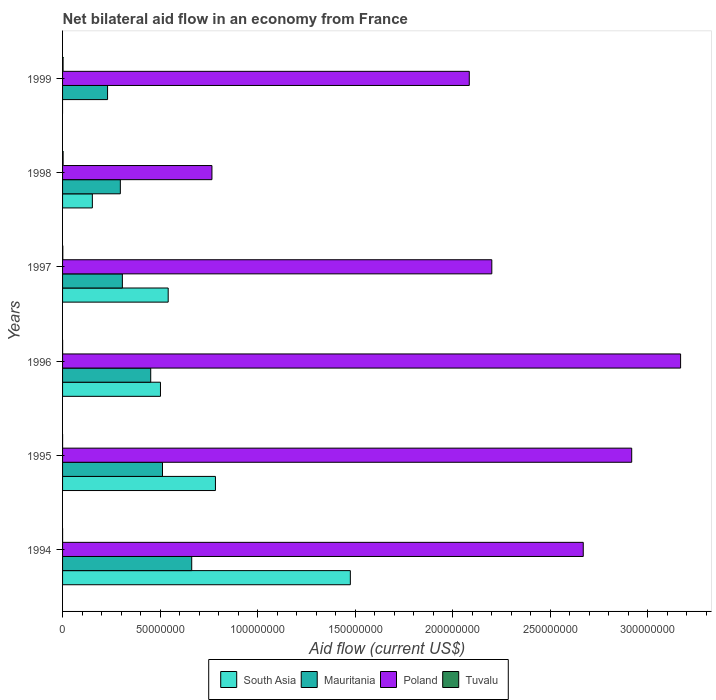How many different coloured bars are there?
Give a very brief answer. 4. How many groups of bars are there?
Ensure brevity in your answer.  6. Are the number of bars per tick equal to the number of legend labels?
Make the answer very short. No. How many bars are there on the 3rd tick from the top?
Your answer should be compact. 4. What is the label of the 2nd group of bars from the top?
Your answer should be compact. 1998. What is the net bilateral aid flow in South Asia in 1998?
Your answer should be compact. 1.53e+07. Across all years, what is the maximum net bilateral aid flow in South Asia?
Your response must be concise. 1.48e+08. What is the total net bilateral aid flow in South Asia in the graph?
Offer a very short reply. 3.46e+08. What is the difference between the net bilateral aid flow in Poland in 1994 and that in 1998?
Ensure brevity in your answer.  1.90e+08. What is the difference between the net bilateral aid flow in Poland in 1994 and the net bilateral aid flow in Tuvalu in 1996?
Your response must be concise. 2.67e+08. What is the average net bilateral aid flow in South Asia per year?
Keep it short and to the point. 5.76e+07. In the year 1995, what is the difference between the net bilateral aid flow in South Asia and net bilateral aid flow in Tuvalu?
Provide a short and direct response. 7.84e+07. In how many years, is the net bilateral aid flow in Mauritania greater than 10000000 US$?
Give a very brief answer. 6. What is the ratio of the net bilateral aid flow in Poland in 1998 to that in 1999?
Provide a short and direct response. 0.37. Is the net bilateral aid flow in Tuvalu in 1994 less than that in 1995?
Offer a very short reply. No. What is the difference between the highest and the second highest net bilateral aid flow in Tuvalu?
Your answer should be very brief. 2.00e+04. Is it the case that in every year, the sum of the net bilateral aid flow in South Asia and net bilateral aid flow in Poland is greater than the sum of net bilateral aid flow in Tuvalu and net bilateral aid flow in Mauritania?
Offer a terse response. Yes. Is it the case that in every year, the sum of the net bilateral aid flow in Poland and net bilateral aid flow in Mauritania is greater than the net bilateral aid flow in Tuvalu?
Offer a terse response. Yes. Are all the bars in the graph horizontal?
Keep it short and to the point. Yes. How many years are there in the graph?
Offer a terse response. 6. What is the difference between two consecutive major ticks on the X-axis?
Your answer should be very brief. 5.00e+07. Are the values on the major ticks of X-axis written in scientific E-notation?
Offer a very short reply. No. Where does the legend appear in the graph?
Your response must be concise. Bottom center. How are the legend labels stacked?
Your answer should be compact. Horizontal. What is the title of the graph?
Your answer should be compact. Net bilateral aid flow in an economy from France. What is the Aid flow (current US$) of South Asia in 1994?
Your answer should be very brief. 1.48e+08. What is the Aid flow (current US$) in Mauritania in 1994?
Provide a short and direct response. 6.62e+07. What is the Aid flow (current US$) of Poland in 1994?
Keep it short and to the point. 2.67e+08. What is the Aid flow (current US$) in Tuvalu in 1994?
Offer a very short reply. 10000. What is the Aid flow (current US$) in South Asia in 1995?
Provide a short and direct response. 7.84e+07. What is the Aid flow (current US$) in Mauritania in 1995?
Offer a terse response. 5.12e+07. What is the Aid flow (current US$) of Poland in 1995?
Your answer should be very brief. 2.92e+08. What is the Aid flow (current US$) in South Asia in 1996?
Offer a terse response. 5.02e+07. What is the Aid flow (current US$) of Mauritania in 1996?
Give a very brief answer. 4.52e+07. What is the Aid flow (current US$) in Poland in 1996?
Your answer should be compact. 3.17e+08. What is the Aid flow (current US$) in Tuvalu in 1996?
Give a very brief answer. 2.00e+04. What is the Aid flow (current US$) of South Asia in 1997?
Keep it short and to the point. 5.42e+07. What is the Aid flow (current US$) in Mauritania in 1997?
Ensure brevity in your answer.  3.07e+07. What is the Aid flow (current US$) of Poland in 1997?
Give a very brief answer. 2.20e+08. What is the Aid flow (current US$) of Tuvalu in 1997?
Provide a succinct answer. 1.30e+05. What is the Aid flow (current US$) of South Asia in 1998?
Your answer should be very brief. 1.53e+07. What is the Aid flow (current US$) of Mauritania in 1998?
Provide a short and direct response. 2.96e+07. What is the Aid flow (current US$) in Poland in 1998?
Make the answer very short. 7.66e+07. What is the Aid flow (current US$) of Mauritania in 1999?
Provide a short and direct response. 2.31e+07. What is the Aid flow (current US$) of Poland in 1999?
Your response must be concise. 2.09e+08. Across all years, what is the maximum Aid flow (current US$) of South Asia?
Your answer should be compact. 1.48e+08. Across all years, what is the maximum Aid flow (current US$) of Mauritania?
Give a very brief answer. 6.62e+07. Across all years, what is the maximum Aid flow (current US$) of Poland?
Give a very brief answer. 3.17e+08. Across all years, what is the minimum Aid flow (current US$) in Mauritania?
Make the answer very short. 2.31e+07. Across all years, what is the minimum Aid flow (current US$) of Poland?
Your response must be concise. 7.66e+07. What is the total Aid flow (current US$) of South Asia in the graph?
Offer a very short reply. 3.46e+08. What is the total Aid flow (current US$) of Mauritania in the graph?
Offer a very short reply. 2.46e+08. What is the total Aid flow (current US$) of Poland in the graph?
Give a very brief answer. 1.38e+09. What is the total Aid flow (current US$) in Tuvalu in the graph?
Give a very brief answer. 7.10e+05. What is the difference between the Aid flow (current US$) in South Asia in 1994 and that in 1995?
Offer a very short reply. 6.92e+07. What is the difference between the Aid flow (current US$) of Mauritania in 1994 and that in 1995?
Offer a very short reply. 1.50e+07. What is the difference between the Aid flow (current US$) of Poland in 1994 and that in 1995?
Keep it short and to the point. -2.48e+07. What is the difference between the Aid flow (current US$) of South Asia in 1994 and that in 1996?
Ensure brevity in your answer.  9.74e+07. What is the difference between the Aid flow (current US$) of Mauritania in 1994 and that in 1996?
Give a very brief answer. 2.10e+07. What is the difference between the Aid flow (current US$) in Poland in 1994 and that in 1996?
Provide a short and direct response. -4.99e+07. What is the difference between the Aid flow (current US$) of South Asia in 1994 and that in 1997?
Your answer should be very brief. 9.34e+07. What is the difference between the Aid flow (current US$) in Mauritania in 1994 and that in 1997?
Your response must be concise. 3.56e+07. What is the difference between the Aid flow (current US$) of Poland in 1994 and that in 1997?
Your answer should be very brief. 4.69e+07. What is the difference between the Aid flow (current US$) of Tuvalu in 1994 and that in 1997?
Your answer should be compact. -1.20e+05. What is the difference between the Aid flow (current US$) of South Asia in 1994 and that in 1998?
Keep it short and to the point. 1.32e+08. What is the difference between the Aid flow (current US$) in Mauritania in 1994 and that in 1998?
Make the answer very short. 3.66e+07. What is the difference between the Aid flow (current US$) in Poland in 1994 and that in 1998?
Your response must be concise. 1.90e+08. What is the difference between the Aid flow (current US$) in Mauritania in 1994 and that in 1999?
Offer a very short reply. 4.32e+07. What is the difference between the Aid flow (current US$) in Poland in 1994 and that in 1999?
Keep it short and to the point. 5.84e+07. What is the difference between the Aid flow (current US$) of South Asia in 1995 and that in 1996?
Make the answer very short. 2.82e+07. What is the difference between the Aid flow (current US$) of Mauritania in 1995 and that in 1996?
Your response must be concise. 6.04e+06. What is the difference between the Aid flow (current US$) in Poland in 1995 and that in 1996?
Your response must be concise. -2.51e+07. What is the difference between the Aid flow (current US$) of South Asia in 1995 and that in 1997?
Offer a terse response. 2.42e+07. What is the difference between the Aid flow (current US$) in Mauritania in 1995 and that in 1997?
Provide a succinct answer. 2.06e+07. What is the difference between the Aid flow (current US$) in Poland in 1995 and that in 1997?
Keep it short and to the point. 7.18e+07. What is the difference between the Aid flow (current US$) of South Asia in 1995 and that in 1998?
Your response must be concise. 6.31e+07. What is the difference between the Aid flow (current US$) of Mauritania in 1995 and that in 1998?
Provide a short and direct response. 2.16e+07. What is the difference between the Aid flow (current US$) of Poland in 1995 and that in 1998?
Ensure brevity in your answer.  2.15e+08. What is the difference between the Aid flow (current US$) in Mauritania in 1995 and that in 1999?
Your answer should be compact. 2.82e+07. What is the difference between the Aid flow (current US$) of Poland in 1995 and that in 1999?
Give a very brief answer. 8.33e+07. What is the difference between the Aid flow (current US$) in Tuvalu in 1995 and that in 1999?
Provide a short and direct response. -2.50e+05. What is the difference between the Aid flow (current US$) in South Asia in 1996 and that in 1997?
Offer a terse response. -3.96e+06. What is the difference between the Aid flow (current US$) of Mauritania in 1996 and that in 1997?
Provide a succinct answer. 1.45e+07. What is the difference between the Aid flow (current US$) in Poland in 1996 and that in 1997?
Make the answer very short. 9.68e+07. What is the difference between the Aid flow (current US$) in South Asia in 1996 and that in 1998?
Give a very brief answer. 3.49e+07. What is the difference between the Aid flow (current US$) in Mauritania in 1996 and that in 1998?
Give a very brief answer. 1.56e+07. What is the difference between the Aid flow (current US$) of Poland in 1996 and that in 1998?
Keep it short and to the point. 2.40e+08. What is the difference between the Aid flow (current US$) in Tuvalu in 1996 and that in 1998?
Keep it short and to the point. -2.60e+05. What is the difference between the Aid flow (current US$) in Mauritania in 1996 and that in 1999?
Ensure brevity in your answer.  2.21e+07. What is the difference between the Aid flow (current US$) of Poland in 1996 and that in 1999?
Your answer should be very brief. 1.08e+08. What is the difference between the Aid flow (current US$) of Tuvalu in 1996 and that in 1999?
Offer a terse response. -2.40e+05. What is the difference between the Aid flow (current US$) of South Asia in 1997 and that in 1998?
Offer a terse response. 3.89e+07. What is the difference between the Aid flow (current US$) in Mauritania in 1997 and that in 1998?
Make the answer very short. 1.04e+06. What is the difference between the Aid flow (current US$) in Poland in 1997 and that in 1998?
Your answer should be compact. 1.44e+08. What is the difference between the Aid flow (current US$) in Mauritania in 1997 and that in 1999?
Give a very brief answer. 7.59e+06. What is the difference between the Aid flow (current US$) of Poland in 1997 and that in 1999?
Give a very brief answer. 1.16e+07. What is the difference between the Aid flow (current US$) of Tuvalu in 1997 and that in 1999?
Your answer should be very brief. -1.30e+05. What is the difference between the Aid flow (current US$) in Mauritania in 1998 and that in 1999?
Offer a very short reply. 6.55e+06. What is the difference between the Aid flow (current US$) of Poland in 1998 and that in 1999?
Offer a very short reply. -1.32e+08. What is the difference between the Aid flow (current US$) in Tuvalu in 1998 and that in 1999?
Provide a succinct answer. 2.00e+04. What is the difference between the Aid flow (current US$) of South Asia in 1994 and the Aid flow (current US$) of Mauritania in 1995?
Ensure brevity in your answer.  9.63e+07. What is the difference between the Aid flow (current US$) in South Asia in 1994 and the Aid flow (current US$) in Poland in 1995?
Offer a very short reply. -1.44e+08. What is the difference between the Aid flow (current US$) in South Asia in 1994 and the Aid flow (current US$) in Tuvalu in 1995?
Offer a very short reply. 1.48e+08. What is the difference between the Aid flow (current US$) of Mauritania in 1994 and the Aid flow (current US$) of Poland in 1995?
Keep it short and to the point. -2.26e+08. What is the difference between the Aid flow (current US$) of Mauritania in 1994 and the Aid flow (current US$) of Tuvalu in 1995?
Provide a short and direct response. 6.62e+07. What is the difference between the Aid flow (current US$) in Poland in 1994 and the Aid flow (current US$) in Tuvalu in 1995?
Provide a short and direct response. 2.67e+08. What is the difference between the Aid flow (current US$) in South Asia in 1994 and the Aid flow (current US$) in Mauritania in 1996?
Offer a very short reply. 1.02e+08. What is the difference between the Aid flow (current US$) of South Asia in 1994 and the Aid flow (current US$) of Poland in 1996?
Provide a succinct answer. -1.69e+08. What is the difference between the Aid flow (current US$) in South Asia in 1994 and the Aid flow (current US$) in Tuvalu in 1996?
Give a very brief answer. 1.48e+08. What is the difference between the Aid flow (current US$) of Mauritania in 1994 and the Aid flow (current US$) of Poland in 1996?
Provide a succinct answer. -2.51e+08. What is the difference between the Aid flow (current US$) of Mauritania in 1994 and the Aid flow (current US$) of Tuvalu in 1996?
Offer a terse response. 6.62e+07. What is the difference between the Aid flow (current US$) in Poland in 1994 and the Aid flow (current US$) in Tuvalu in 1996?
Give a very brief answer. 2.67e+08. What is the difference between the Aid flow (current US$) of South Asia in 1994 and the Aid flow (current US$) of Mauritania in 1997?
Your answer should be very brief. 1.17e+08. What is the difference between the Aid flow (current US$) in South Asia in 1994 and the Aid flow (current US$) in Poland in 1997?
Your response must be concise. -7.26e+07. What is the difference between the Aid flow (current US$) in South Asia in 1994 and the Aid flow (current US$) in Tuvalu in 1997?
Offer a terse response. 1.47e+08. What is the difference between the Aid flow (current US$) of Mauritania in 1994 and the Aid flow (current US$) of Poland in 1997?
Offer a very short reply. -1.54e+08. What is the difference between the Aid flow (current US$) in Mauritania in 1994 and the Aid flow (current US$) in Tuvalu in 1997?
Offer a terse response. 6.61e+07. What is the difference between the Aid flow (current US$) of Poland in 1994 and the Aid flow (current US$) of Tuvalu in 1997?
Ensure brevity in your answer.  2.67e+08. What is the difference between the Aid flow (current US$) of South Asia in 1994 and the Aid flow (current US$) of Mauritania in 1998?
Keep it short and to the point. 1.18e+08. What is the difference between the Aid flow (current US$) in South Asia in 1994 and the Aid flow (current US$) in Poland in 1998?
Keep it short and to the point. 7.10e+07. What is the difference between the Aid flow (current US$) in South Asia in 1994 and the Aid flow (current US$) in Tuvalu in 1998?
Offer a terse response. 1.47e+08. What is the difference between the Aid flow (current US$) of Mauritania in 1994 and the Aid flow (current US$) of Poland in 1998?
Provide a succinct answer. -1.04e+07. What is the difference between the Aid flow (current US$) of Mauritania in 1994 and the Aid flow (current US$) of Tuvalu in 1998?
Provide a succinct answer. 6.60e+07. What is the difference between the Aid flow (current US$) of Poland in 1994 and the Aid flow (current US$) of Tuvalu in 1998?
Give a very brief answer. 2.67e+08. What is the difference between the Aid flow (current US$) of South Asia in 1994 and the Aid flow (current US$) of Mauritania in 1999?
Keep it short and to the point. 1.25e+08. What is the difference between the Aid flow (current US$) of South Asia in 1994 and the Aid flow (current US$) of Poland in 1999?
Provide a succinct answer. -6.10e+07. What is the difference between the Aid flow (current US$) of South Asia in 1994 and the Aid flow (current US$) of Tuvalu in 1999?
Your answer should be very brief. 1.47e+08. What is the difference between the Aid flow (current US$) in Mauritania in 1994 and the Aid flow (current US$) in Poland in 1999?
Your answer should be compact. -1.42e+08. What is the difference between the Aid flow (current US$) in Mauritania in 1994 and the Aid flow (current US$) in Tuvalu in 1999?
Ensure brevity in your answer.  6.60e+07. What is the difference between the Aid flow (current US$) of Poland in 1994 and the Aid flow (current US$) of Tuvalu in 1999?
Offer a very short reply. 2.67e+08. What is the difference between the Aid flow (current US$) in South Asia in 1995 and the Aid flow (current US$) in Mauritania in 1996?
Your response must be concise. 3.32e+07. What is the difference between the Aid flow (current US$) in South Asia in 1995 and the Aid flow (current US$) in Poland in 1996?
Your response must be concise. -2.39e+08. What is the difference between the Aid flow (current US$) in South Asia in 1995 and the Aid flow (current US$) in Tuvalu in 1996?
Make the answer very short. 7.84e+07. What is the difference between the Aid flow (current US$) of Mauritania in 1995 and the Aid flow (current US$) of Poland in 1996?
Make the answer very short. -2.66e+08. What is the difference between the Aid flow (current US$) in Mauritania in 1995 and the Aid flow (current US$) in Tuvalu in 1996?
Provide a short and direct response. 5.12e+07. What is the difference between the Aid flow (current US$) of Poland in 1995 and the Aid flow (current US$) of Tuvalu in 1996?
Your answer should be compact. 2.92e+08. What is the difference between the Aid flow (current US$) in South Asia in 1995 and the Aid flow (current US$) in Mauritania in 1997?
Provide a succinct answer. 4.77e+07. What is the difference between the Aid flow (current US$) in South Asia in 1995 and the Aid flow (current US$) in Poland in 1997?
Keep it short and to the point. -1.42e+08. What is the difference between the Aid flow (current US$) in South Asia in 1995 and the Aid flow (current US$) in Tuvalu in 1997?
Ensure brevity in your answer.  7.83e+07. What is the difference between the Aid flow (current US$) in Mauritania in 1995 and the Aid flow (current US$) in Poland in 1997?
Offer a terse response. -1.69e+08. What is the difference between the Aid flow (current US$) of Mauritania in 1995 and the Aid flow (current US$) of Tuvalu in 1997?
Ensure brevity in your answer.  5.11e+07. What is the difference between the Aid flow (current US$) of Poland in 1995 and the Aid flow (current US$) of Tuvalu in 1997?
Give a very brief answer. 2.92e+08. What is the difference between the Aid flow (current US$) of South Asia in 1995 and the Aid flow (current US$) of Mauritania in 1998?
Provide a succinct answer. 4.88e+07. What is the difference between the Aid flow (current US$) in South Asia in 1995 and the Aid flow (current US$) in Poland in 1998?
Provide a succinct answer. 1.79e+06. What is the difference between the Aid flow (current US$) of South Asia in 1995 and the Aid flow (current US$) of Tuvalu in 1998?
Your answer should be very brief. 7.81e+07. What is the difference between the Aid flow (current US$) in Mauritania in 1995 and the Aid flow (current US$) in Poland in 1998?
Keep it short and to the point. -2.54e+07. What is the difference between the Aid flow (current US$) of Mauritania in 1995 and the Aid flow (current US$) of Tuvalu in 1998?
Your answer should be compact. 5.10e+07. What is the difference between the Aid flow (current US$) of Poland in 1995 and the Aid flow (current US$) of Tuvalu in 1998?
Provide a succinct answer. 2.92e+08. What is the difference between the Aid flow (current US$) in South Asia in 1995 and the Aid flow (current US$) in Mauritania in 1999?
Offer a terse response. 5.53e+07. What is the difference between the Aid flow (current US$) in South Asia in 1995 and the Aid flow (current US$) in Poland in 1999?
Make the answer very short. -1.30e+08. What is the difference between the Aid flow (current US$) in South Asia in 1995 and the Aid flow (current US$) in Tuvalu in 1999?
Provide a short and direct response. 7.81e+07. What is the difference between the Aid flow (current US$) of Mauritania in 1995 and the Aid flow (current US$) of Poland in 1999?
Make the answer very short. -1.57e+08. What is the difference between the Aid flow (current US$) in Mauritania in 1995 and the Aid flow (current US$) in Tuvalu in 1999?
Make the answer very short. 5.10e+07. What is the difference between the Aid flow (current US$) in Poland in 1995 and the Aid flow (current US$) in Tuvalu in 1999?
Offer a very short reply. 2.92e+08. What is the difference between the Aid flow (current US$) in South Asia in 1996 and the Aid flow (current US$) in Mauritania in 1997?
Your response must be concise. 1.95e+07. What is the difference between the Aid flow (current US$) of South Asia in 1996 and the Aid flow (current US$) of Poland in 1997?
Your answer should be very brief. -1.70e+08. What is the difference between the Aid flow (current US$) in South Asia in 1996 and the Aid flow (current US$) in Tuvalu in 1997?
Keep it short and to the point. 5.01e+07. What is the difference between the Aid flow (current US$) in Mauritania in 1996 and the Aid flow (current US$) in Poland in 1997?
Make the answer very short. -1.75e+08. What is the difference between the Aid flow (current US$) of Mauritania in 1996 and the Aid flow (current US$) of Tuvalu in 1997?
Your answer should be very brief. 4.51e+07. What is the difference between the Aid flow (current US$) of Poland in 1996 and the Aid flow (current US$) of Tuvalu in 1997?
Provide a short and direct response. 3.17e+08. What is the difference between the Aid flow (current US$) in South Asia in 1996 and the Aid flow (current US$) in Mauritania in 1998?
Your answer should be compact. 2.06e+07. What is the difference between the Aid flow (current US$) in South Asia in 1996 and the Aid flow (current US$) in Poland in 1998?
Your answer should be very brief. -2.64e+07. What is the difference between the Aid flow (current US$) of South Asia in 1996 and the Aid flow (current US$) of Tuvalu in 1998?
Give a very brief answer. 4.99e+07. What is the difference between the Aid flow (current US$) of Mauritania in 1996 and the Aid flow (current US$) of Poland in 1998?
Your answer should be compact. -3.14e+07. What is the difference between the Aid flow (current US$) of Mauritania in 1996 and the Aid flow (current US$) of Tuvalu in 1998?
Give a very brief answer. 4.49e+07. What is the difference between the Aid flow (current US$) in Poland in 1996 and the Aid flow (current US$) in Tuvalu in 1998?
Your response must be concise. 3.17e+08. What is the difference between the Aid flow (current US$) of South Asia in 1996 and the Aid flow (current US$) of Mauritania in 1999?
Your answer should be compact. 2.71e+07. What is the difference between the Aid flow (current US$) of South Asia in 1996 and the Aid flow (current US$) of Poland in 1999?
Your response must be concise. -1.58e+08. What is the difference between the Aid flow (current US$) of South Asia in 1996 and the Aid flow (current US$) of Tuvalu in 1999?
Your response must be concise. 5.00e+07. What is the difference between the Aid flow (current US$) in Mauritania in 1996 and the Aid flow (current US$) in Poland in 1999?
Your answer should be very brief. -1.63e+08. What is the difference between the Aid flow (current US$) in Mauritania in 1996 and the Aid flow (current US$) in Tuvalu in 1999?
Give a very brief answer. 4.50e+07. What is the difference between the Aid flow (current US$) of Poland in 1996 and the Aid flow (current US$) of Tuvalu in 1999?
Your answer should be very brief. 3.17e+08. What is the difference between the Aid flow (current US$) in South Asia in 1997 and the Aid flow (current US$) in Mauritania in 1998?
Offer a very short reply. 2.45e+07. What is the difference between the Aid flow (current US$) in South Asia in 1997 and the Aid flow (current US$) in Poland in 1998?
Make the answer very short. -2.24e+07. What is the difference between the Aid flow (current US$) in South Asia in 1997 and the Aid flow (current US$) in Tuvalu in 1998?
Your response must be concise. 5.39e+07. What is the difference between the Aid flow (current US$) in Mauritania in 1997 and the Aid flow (current US$) in Poland in 1998?
Offer a terse response. -4.59e+07. What is the difference between the Aid flow (current US$) of Mauritania in 1997 and the Aid flow (current US$) of Tuvalu in 1998?
Give a very brief answer. 3.04e+07. What is the difference between the Aid flow (current US$) of Poland in 1997 and the Aid flow (current US$) of Tuvalu in 1998?
Make the answer very short. 2.20e+08. What is the difference between the Aid flow (current US$) of South Asia in 1997 and the Aid flow (current US$) of Mauritania in 1999?
Ensure brevity in your answer.  3.11e+07. What is the difference between the Aid flow (current US$) of South Asia in 1997 and the Aid flow (current US$) of Poland in 1999?
Offer a terse response. -1.54e+08. What is the difference between the Aid flow (current US$) in South Asia in 1997 and the Aid flow (current US$) in Tuvalu in 1999?
Provide a succinct answer. 5.39e+07. What is the difference between the Aid flow (current US$) in Mauritania in 1997 and the Aid flow (current US$) in Poland in 1999?
Your answer should be compact. -1.78e+08. What is the difference between the Aid flow (current US$) of Mauritania in 1997 and the Aid flow (current US$) of Tuvalu in 1999?
Your response must be concise. 3.04e+07. What is the difference between the Aid flow (current US$) of Poland in 1997 and the Aid flow (current US$) of Tuvalu in 1999?
Ensure brevity in your answer.  2.20e+08. What is the difference between the Aid flow (current US$) in South Asia in 1998 and the Aid flow (current US$) in Mauritania in 1999?
Provide a succinct answer. -7.80e+06. What is the difference between the Aid flow (current US$) in South Asia in 1998 and the Aid flow (current US$) in Poland in 1999?
Give a very brief answer. -1.93e+08. What is the difference between the Aid flow (current US$) of South Asia in 1998 and the Aid flow (current US$) of Tuvalu in 1999?
Provide a short and direct response. 1.50e+07. What is the difference between the Aid flow (current US$) in Mauritania in 1998 and the Aid flow (current US$) in Poland in 1999?
Your response must be concise. -1.79e+08. What is the difference between the Aid flow (current US$) in Mauritania in 1998 and the Aid flow (current US$) in Tuvalu in 1999?
Keep it short and to the point. 2.94e+07. What is the difference between the Aid flow (current US$) of Poland in 1998 and the Aid flow (current US$) of Tuvalu in 1999?
Keep it short and to the point. 7.64e+07. What is the average Aid flow (current US$) in South Asia per year?
Give a very brief answer. 5.76e+07. What is the average Aid flow (current US$) of Mauritania per year?
Offer a terse response. 4.10e+07. What is the average Aid flow (current US$) of Poland per year?
Ensure brevity in your answer.  2.30e+08. What is the average Aid flow (current US$) in Tuvalu per year?
Provide a short and direct response. 1.18e+05. In the year 1994, what is the difference between the Aid flow (current US$) in South Asia and Aid flow (current US$) in Mauritania?
Offer a terse response. 8.14e+07. In the year 1994, what is the difference between the Aid flow (current US$) of South Asia and Aid flow (current US$) of Poland?
Make the answer very short. -1.19e+08. In the year 1994, what is the difference between the Aid flow (current US$) of South Asia and Aid flow (current US$) of Tuvalu?
Give a very brief answer. 1.48e+08. In the year 1994, what is the difference between the Aid flow (current US$) in Mauritania and Aid flow (current US$) in Poland?
Offer a very short reply. -2.01e+08. In the year 1994, what is the difference between the Aid flow (current US$) of Mauritania and Aid flow (current US$) of Tuvalu?
Your answer should be very brief. 6.62e+07. In the year 1994, what is the difference between the Aid flow (current US$) in Poland and Aid flow (current US$) in Tuvalu?
Your answer should be very brief. 2.67e+08. In the year 1995, what is the difference between the Aid flow (current US$) of South Asia and Aid flow (current US$) of Mauritania?
Ensure brevity in your answer.  2.72e+07. In the year 1995, what is the difference between the Aid flow (current US$) in South Asia and Aid flow (current US$) in Poland?
Offer a terse response. -2.13e+08. In the year 1995, what is the difference between the Aid flow (current US$) of South Asia and Aid flow (current US$) of Tuvalu?
Make the answer very short. 7.84e+07. In the year 1995, what is the difference between the Aid flow (current US$) in Mauritania and Aid flow (current US$) in Poland?
Your response must be concise. -2.41e+08. In the year 1995, what is the difference between the Aid flow (current US$) in Mauritania and Aid flow (current US$) in Tuvalu?
Your response must be concise. 5.12e+07. In the year 1995, what is the difference between the Aid flow (current US$) in Poland and Aid flow (current US$) in Tuvalu?
Make the answer very short. 2.92e+08. In the year 1996, what is the difference between the Aid flow (current US$) of South Asia and Aid flow (current US$) of Poland?
Offer a terse response. -2.67e+08. In the year 1996, what is the difference between the Aid flow (current US$) of South Asia and Aid flow (current US$) of Tuvalu?
Make the answer very short. 5.02e+07. In the year 1996, what is the difference between the Aid flow (current US$) in Mauritania and Aid flow (current US$) in Poland?
Provide a succinct answer. -2.72e+08. In the year 1996, what is the difference between the Aid flow (current US$) in Mauritania and Aid flow (current US$) in Tuvalu?
Your answer should be very brief. 4.52e+07. In the year 1996, what is the difference between the Aid flow (current US$) in Poland and Aid flow (current US$) in Tuvalu?
Give a very brief answer. 3.17e+08. In the year 1997, what is the difference between the Aid flow (current US$) in South Asia and Aid flow (current US$) in Mauritania?
Ensure brevity in your answer.  2.35e+07. In the year 1997, what is the difference between the Aid flow (current US$) of South Asia and Aid flow (current US$) of Poland?
Give a very brief answer. -1.66e+08. In the year 1997, what is the difference between the Aid flow (current US$) of South Asia and Aid flow (current US$) of Tuvalu?
Give a very brief answer. 5.40e+07. In the year 1997, what is the difference between the Aid flow (current US$) in Mauritania and Aid flow (current US$) in Poland?
Provide a short and direct response. -1.89e+08. In the year 1997, what is the difference between the Aid flow (current US$) of Mauritania and Aid flow (current US$) of Tuvalu?
Your response must be concise. 3.05e+07. In the year 1997, what is the difference between the Aid flow (current US$) in Poland and Aid flow (current US$) in Tuvalu?
Offer a terse response. 2.20e+08. In the year 1998, what is the difference between the Aid flow (current US$) in South Asia and Aid flow (current US$) in Mauritania?
Your answer should be compact. -1.44e+07. In the year 1998, what is the difference between the Aid flow (current US$) of South Asia and Aid flow (current US$) of Poland?
Offer a very short reply. -6.13e+07. In the year 1998, what is the difference between the Aid flow (current US$) of South Asia and Aid flow (current US$) of Tuvalu?
Offer a very short reply. 1.50e+07. In the year 1998, what is the difference between the Aid flow (current US$) of Mauritania and Aid flow (current US$) of Poland?
Provide a short and direct response. -4.70e+07. In the year 1998, what is the difference between the Aid flow (current US$) in Mauritania and Aid flow (current US$) in Tuvalu?
Provide a succinct answer. 2.94e+07. In the year 1998, what is the difference between the Aid flow (current US$) in Poland and Aid flow (current US$) in Tuvalu?
Offer a terse response. 7.63e+07. In the year 1999, what is the difference between the Aid flow (current US$) of Mauritania and Aid flow (current US$) of Poland?
Ensure brevity in your answer.  -1.86e+08. In the year 1999, what is the difference between the Aid flow (current US$) of Mauritania and Aid flow (current US$) of Tuvalu?
Offer a terse response. 2.28e+07. In the year 1999, what is the difference between the Aid flow (current US$) in Poland and Aid flow (current US$) in Tuvalu?
Offer a terse response. 2.08e+08. What is the ratio of the Aid flow (current US$) in South Asia in 1994 to that in 1995?
Keep it short and to the point. 1.88. What is the ratio of the Aid flow (current US$) in Mauritania in 1994 to that in 1995?
Keep it short and to the point. 1.29. What is the ratio of the Aid flow (current US$) in Poland in 1994 to that in 1995?
Give a very brief answer. 0.91. What is the ratio of the Aid flow (current US$) in Tuvalu in 1994 to that in 1995?
Provide a short and direct response. 1. What is the ratio of the Aid flow (current US$) in South Asia in 1994 to that in 1996?
Provide a succinct answer. 2.94. What is the ratio of the Aid flow (current US$) of Mauritania in 1994 to that in 1996?
Keep it short and to the point. 1.47. What is the ratio of the Aid flow (current US$) of Poland in 1994 to that in 1996?
Offer a very short reply. 0.84. What is the ratio of the Aid flow (current US$) of Tuvalu in 1994 to that in 1996?
Give a very brief answer. 0.5. What is the ratio of the Aid flow (current US$) of South Asia in 1994 to that in 1997?
Provide a short and direct response. 2.72. What is the ratio of the Aid flow (current US$) of Mauritania in 1994 to that in 1997?
Your answer should be very brief. 2.16. What is the ratio of the Aid flow (current US$) in Poland in 1994 to that in 1997?
Offer a very short reply. 1.21. What is the ratio of the Aid flow (current US$) of Tuvalu in 1994 to that in 1997?
Your answer should be very brief. 0.08. What is the ratio of the Aid flow (current US$) in South Asia in 1994 to that in 1998?
Your answer should be very brief. 9.66. What is the ratio of the Aid flow (current US$) in Mauritania in 1994 to that in 1998?
Ensure brevity in your answer.  2.24. What is the ratio of the Aid flow (current US$) of Poland in 1994 to that in 1998?
Your answer should be compact. 3.49. What is the ratio of the Aid flow (current US$) in Tuvalu in 1994 to that in 1998?
Provide a succinct answer. 0.04. What is the ratio of the Aid flow (current US$) of Mauritania in 1994 to that in 1999?
Offer a very short reply. 2.87. What is the ratio of the Aid flow (current US$) of Poland in 1994 to that in 1999?
Give a very brief answer. 1.28. What is the ratio of the Aid flow (current US$) of Tuvalu in 1994 to that in 1999?
Offer a very short reply. 0.04. What is the ratio of the Aid flow (current US$) in South Asia in 1995 to that in 1996?
Your response must be concise. 1.56. What is the ratio of the Aid flow (current US$) of Mauritania in 1995 to that in 1996?
Ensure brevity in your answer.  1.13. What is the ratio of the Aid flow (current US$) in Poland in 1995 to that in 1996?
Offer a terse response. 0.92. What is the ratio of the Aid flow (current US$) in Tuvalu in 1995 to that in 1996?
Provide a short and direct response. 0.5. What is the ratio of the Aid flow (current US$) in South Asia in 1995 to that in 1997?
Give a very brief answer. 1.45. What is the ratio of the Aid flow (current US$) of Mauritania in 1995 to that in 1997?
Keep it short and to the point. 1.67. What is the ratio of the Aid flow (current US$) in Poland in 1995 to that in 1997?
Your answer should be compact. 1.33. What is the ratio of the Aid flow (current US$) in Tuvalu in 1995 to that in 1997?
Offer a very short reply. 0.08. What is the ratio of the Aid flow (current US$) in South Asia in 1995 to that in 1998?
Give a very brief answer. 5.13. What is the ratio of the Aid flow (current US$) of Mauritania in 1995 to that in 1998?
Offer a very short reply. 1.73. What is the ratio of the Aid flow (current US$) of Poland in 1995 to that in 1998?
Ensure brevity in your answer.  3.81. What is the ratio of the Aid flow (current US$) of Tuvalu in 1995 to that in 1998?
Offer a terse response. 0.04. What is the ratio of the Aid flow (current US$) of Mauritania in 1995 to that in 1999?
Ensure brevity in your answer.  2.22. What is the ratio of the Aid flow (current US$) in Poland in 1995 to that in 1999?
Keep it short and to the point. 1.4. What is the ratio of the Aid flow (current US$) of Tuvalu in 1995 to that in 1999?
Offer a terse response. 0.04. What is the ratio of the Aid flow (current US$) in South Asia in 1996 to that in 1997?
Your answer should be very brief. 0.93. What is the ratio of the Aid flow (current US$) in Mauritania in 1996 to that in 1997?
Provide a succinct answer. 1.47. What is the ratio of the Aid flow (current US$) of Poland in 1996 to that in 1997?
Offer a terse response. 1.44. What is the ratio of the Aid flow (current US$) of Tuvalu in 1996 to that in 1997?
Provide a succinct answer. 0.15. What is the ratio of the Aid flow (current US$) in South Asia in 1996 to that in 1998?
Your answer should be very brief. 3.29. What is the ratio of the Aid flow (current US$) in Mauritania in 1996 to that in 1998?
Your response must be concise. 1.53. What is the ratio of the Aid flow (current US$) in Poland in 1996 to that in 1998?
Provide a short and direct response. 4.14. What is the ratio of the Aid flow (current US$) of Tuvalu in 1996 to that in 1998?
Your response must be concise. 0.07. What is the ratio of the Aid flow (current US$) in Mauritania in 1996 to that in 1999?
Keep it short and to the point. 1.96. What is the ratio of the Aid flow (current US$) in Poland in 1996 to that in 1999?
Give a very brief answer. 1.52. What is the ratio of the Aid flow (current US$) in Tuvalu in 1996 to that in 1999?
Your response must be concise. 0.08. What is the ratio of the Aid flow (current US$) of South Asia in 1997 to that in 1998?
Offer a terse response. 3.55. What is the ratio of the Aid flow (current US$) in Mauritania in 1997 to that in 1998?
Your answer should be compact. 1.04. What is the ratio of the Aid flow (current US$) of Poland in 1997 to that in 1998?
Keep it short and to the point. 2.87. What is the ratio of the Aid flow (current US$) in Tuvalu in 1997 to that in 1998?
Keep it short and to the point. 0.46. What is the ratio of the Aid flow (current US$) of Mauritania in 1997 to that in 1999?
Your answer should be very brief. 1.33. What is the ratio of the Aid flow (current US$) in Poland in 1997 to that in 1999?
Ensure brevity in your answer.  1.06. What is the ratio of the Aid flow (current US$) of Mauritania in 1998 to that in 1999?
Give a very brief answer. 1.28. What is the ratio of the Aid flow (current US$) in Poland in 1998 to that in 1999?
Make the answer very short. 0.37. What is the difference between the highest and the second highest Aid flow (current US$) of South Asia?
Give a very brief answer. 6.92e+07. What is the difference between the highest and the second highest Aid flow (current US$) in Mauritania?
Offer a very short reply. 1.50e+07. What is the difference between the highest and the second highest Aid flow (current US$) in Poland?
Give a very brief answer. 2.51e+07. What is the difference between the highest and the lowest Aid flow (current US$) of South Asia?
Your response must be concise. 1.48e+08. What is the difference between the highest and the lowest Aid flow (current US$) of Mauritania?
Offer a terse response. 4.32e+07. What is the difference between the highest and the lowest Aid flow (current US$) in Poland?
Make the answer very short. 2.40e+08. What is the difference between the highest and the lowest Aid flow (current US$) in Tuvalu?
Provide a short and direct response. 2.70e+05. 